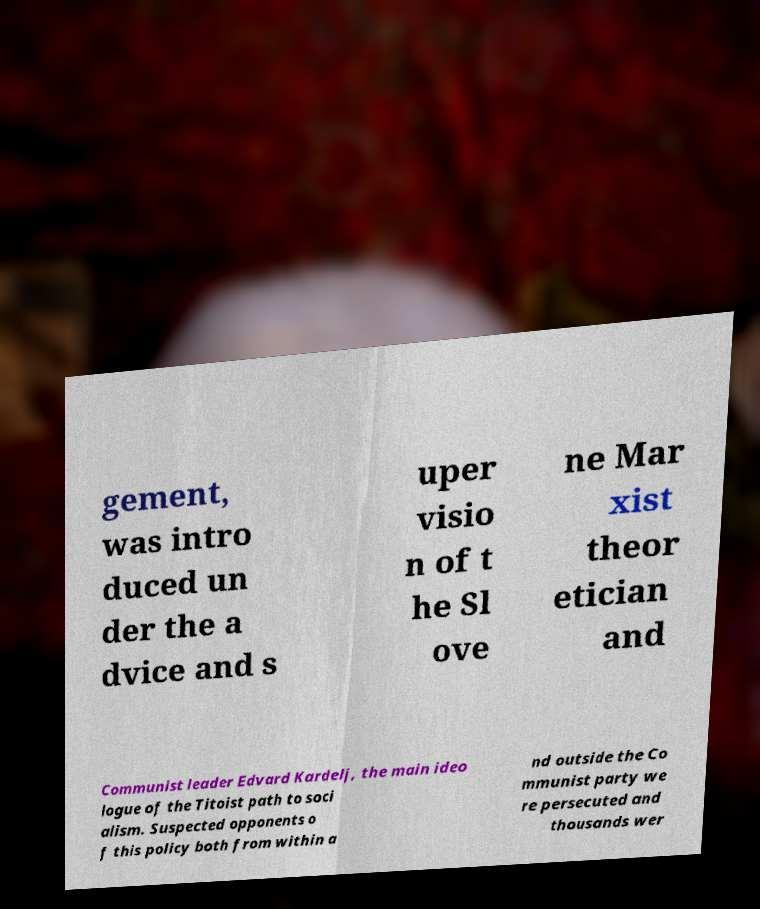For documentation purposes, I need the text within this image transcribed. Could you provide that? gement, was intro duced un der the a dvice and s uper visio n of t he Sl ove ne Mar xist theor etician and Communist leader Edvard Kardelj, the main ideo logue of the Titoist path to soci alism. Suspected opponents o f this policy both from within a nd outside the Co mmunist party we re persecuted and thousands wer 